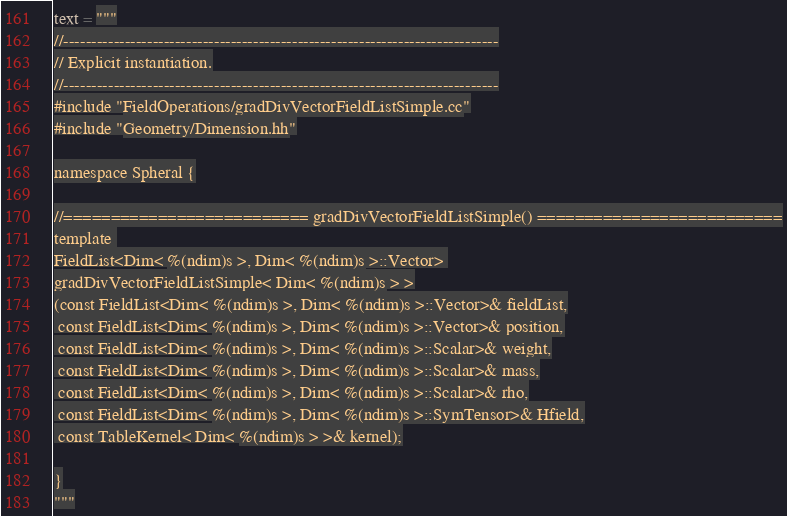<code> <loc_0><loc_0><loc_500><loc_500><_Python_>text = """
//------------------------------------------------------------------------------
// Explicit instantiation.
//------------------------------------------------------------------------------
#include "FieldOperations/gradDivVectorFieldListSimple.cc"
#include "Geometry/Dimension.hh"

namespace Spheral {

//========================== gradDivVectorFieldListSimple() ==========================
template 
FieldList<Dim< %(ndim)s >, Dim< %(ndim)s >::Vector> 
gradDivVectorFieldListSimple< Dim< %(ndim)s > >
(const FieldList<Dim< %(ndim)s >, Dim< %(ndim)s >::Vector>& fieldList,
 const FieldList<Dim< %(ndim)s >, Dim< %(ndim)s >::Vector>& position,
 const FieldList<Dim< %(ndim)s >, Dim< %(ndim)s >::Scalar>& weight,
 const FieldList<Dim< %(ndim)s >, Dim< %(ndim)s >::Scalar>& mass,
 const FieldList<Dim< %(ndim)s >, Dim< %(ndim)s >::Scalar>& rho,
 const FieldList<Dim< %(ndim)s >, Dim< %(ndim)s >::SymTensor>& Hfield,
 const TableKernel< Dim< %(ndim)s > >& kernel);

}
"""
</code> 